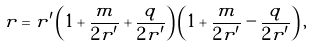Convert formula to latex. <formula><loc_0><loc_0><loc_500><loc_500>r = r ^ { \prime } \left ( 1 + \frac { m } { 2 r ^ { \prime } } + \frac { q } { 2 r ^ { \prime } } \right ) \left ( 1 + \frac { m } { 2 r ^ { \prime } } - \frac { q } { 2 r ^ { \prime } } \right ) ,</formula> 